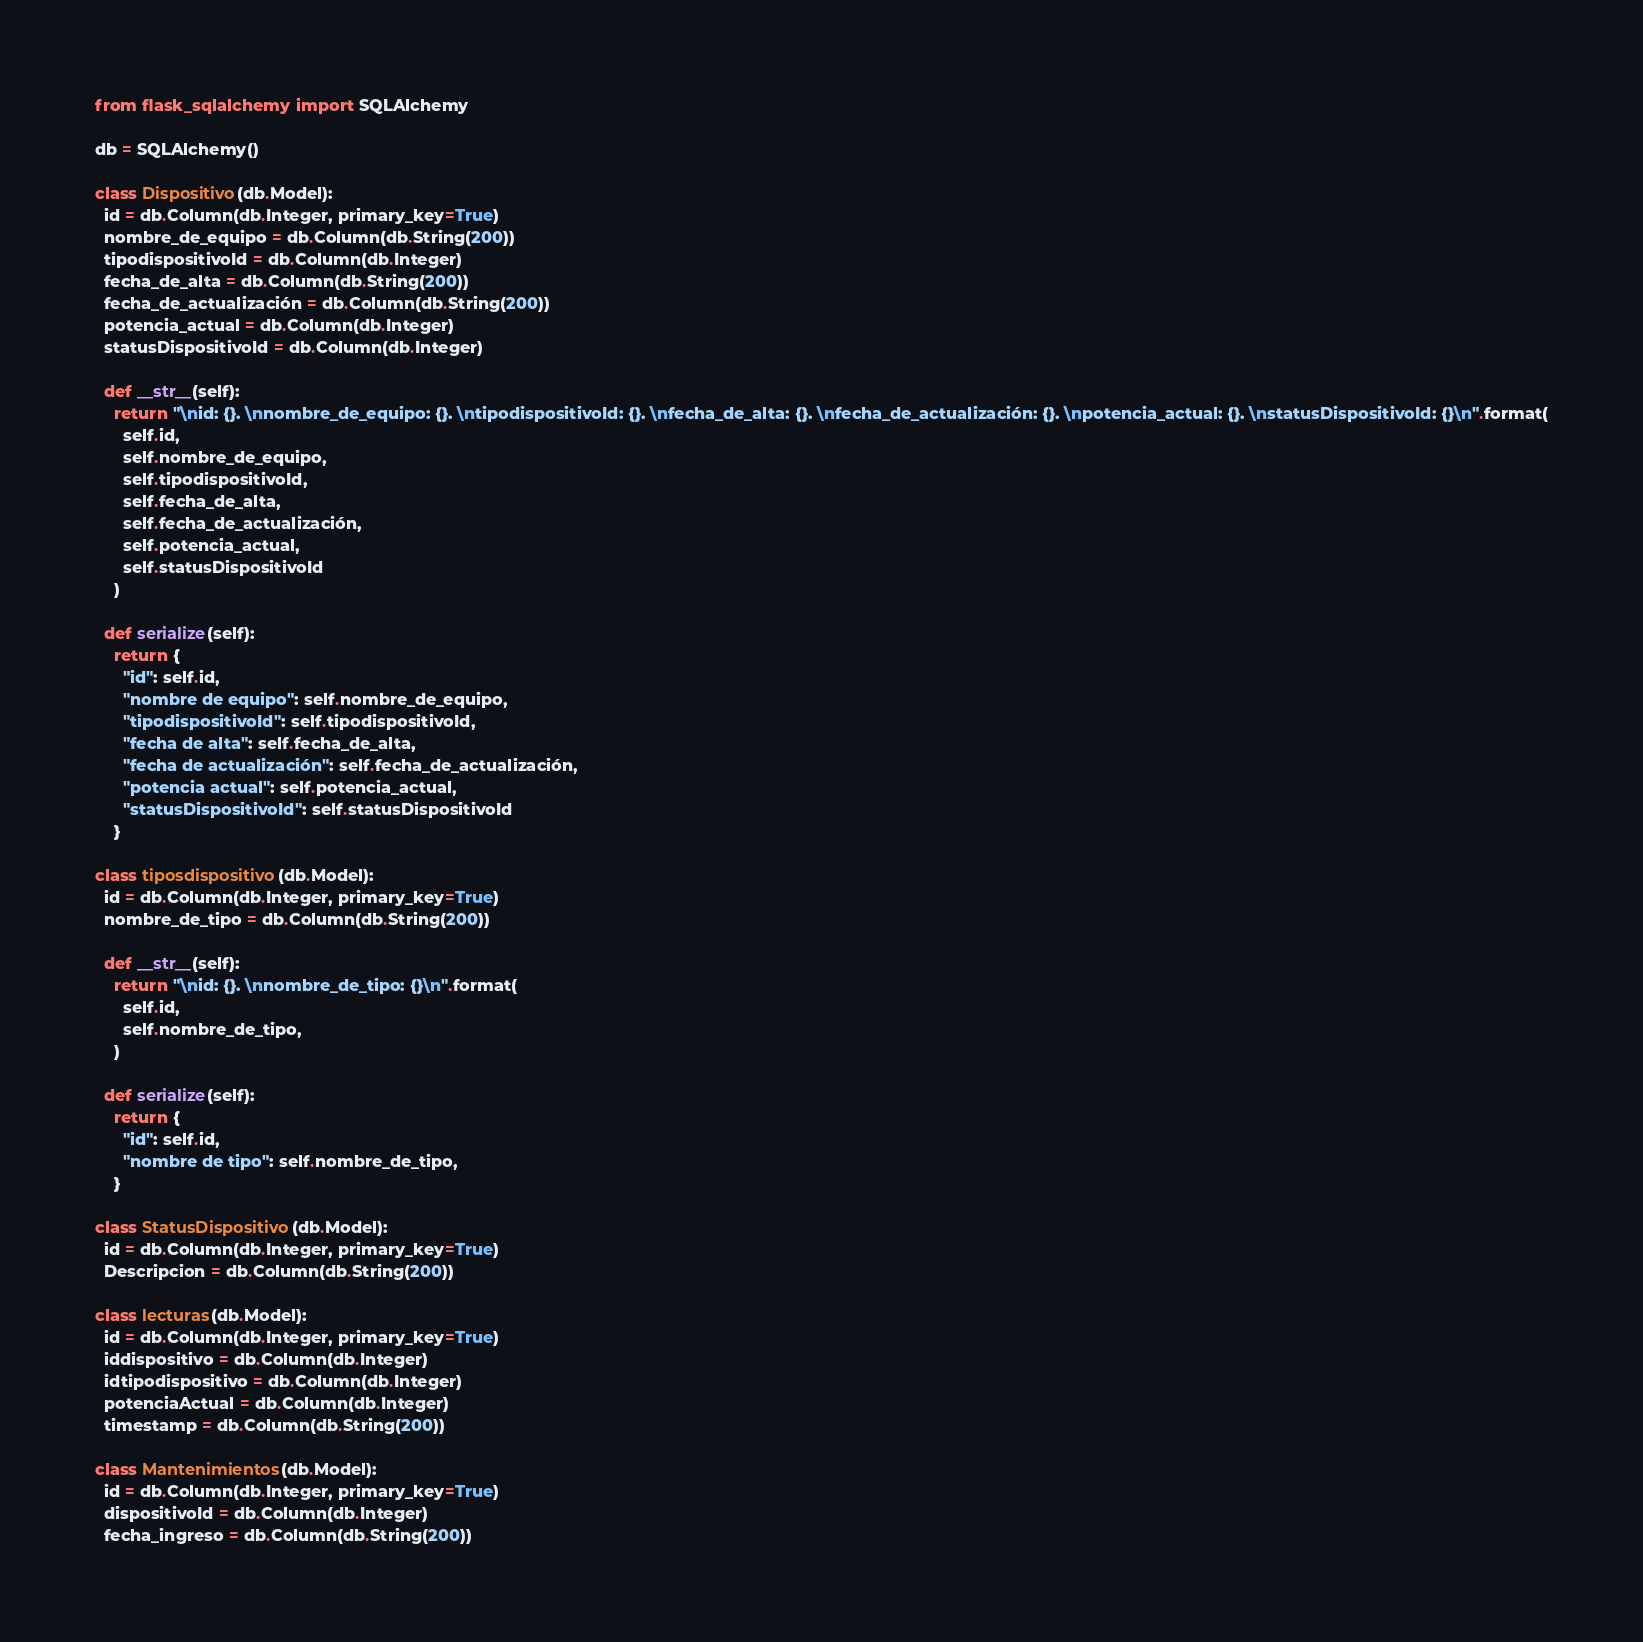<code> <loc_0><loc_0><loc_500><loc_500><_Python_>from flask_sqlalchemy import SQLAlchemy

db = SQLAlchemy()

class Dispositivo(db.Model):
  id = db.Column(db.Integer, primary_key=True)
  nombre_de_equipo = db.Column(db.String(200))
  tipodispositivoId = db.Column(db.Integer)
  fecha_de_alta = db.Column(db.String(200))
  fecha_de_actualización = db.Column(db.String(200))
  potencia_actual = db.Column(db.Integer)
  statusDispositivoId = db.Column(db.Integer)

  def __str__(self):
    return "\nid: {}. \nnombre_de_equipo: {}. \ntipodispositivoId: {}. \nfecha_de_alta: {}. \nfecha_de_actualización: {}. \npotencia_actual: {}. \nstatusDispositivoId: {}\n".format(
      self.id,
      self.nombre_de_equipo,
      self.tipodispositivoId,
      self.fecha_de_alta,
      self.fecha_de_actualización,
      self.potencia_actual,
      self.statusDispositivoId
    )

  def serialize(self):
    return {
      "id": self.id,
      "nombre de equipo": self.nombre_de_equipo,
      "tipodispositivoId": self.tipodispositivoId,
      "fecha de alta": self.fecha_de_alta,
      "fecha de actualización": self.fecha_de_actualización,
      "potencia actual": self.potencia_actual,
      "statusDispositivoId": self.statusDispositivoId
    }

class tiposdispositivo(db.Model):
  id = db.Column(db.Integer, primary_key=True)
  nombre_de_tipo = db.Column(db.String(200))

  def __str__(self):
    return "\nid: {}. \nnombre_de_tipo: {}\n".format(
      self.id,
      self.nombre_de_tipo,
    )

  def serialize(self):
    return {
      "id": self.id,
      "nombre de tipo": self.nombre_de_tipo,
    }

class StatusDispositivo(db.Model):
  id = db.Column(db.Integer, primary_key=True)
  Descripcion = db.Column(db.String(200))

class lecturas(db.Model):
  id = db.Column(db.Integer, primary_key=True)
  iddispositivo = db.Column(db.Integer)
  idtipodispositivo = db.Column(db.Integer)
  potenciaActual = db.Column(db.Integer)
  timestamp = db.Column(db.String(200))

class Mantenimientos(db.Model):
  id = db.Column(db.Integer, primary_key=True)
  dispositivoId = db.Column(db.Integer)
  fecha_ingreso = db.Column(db.String(200))

</code> 